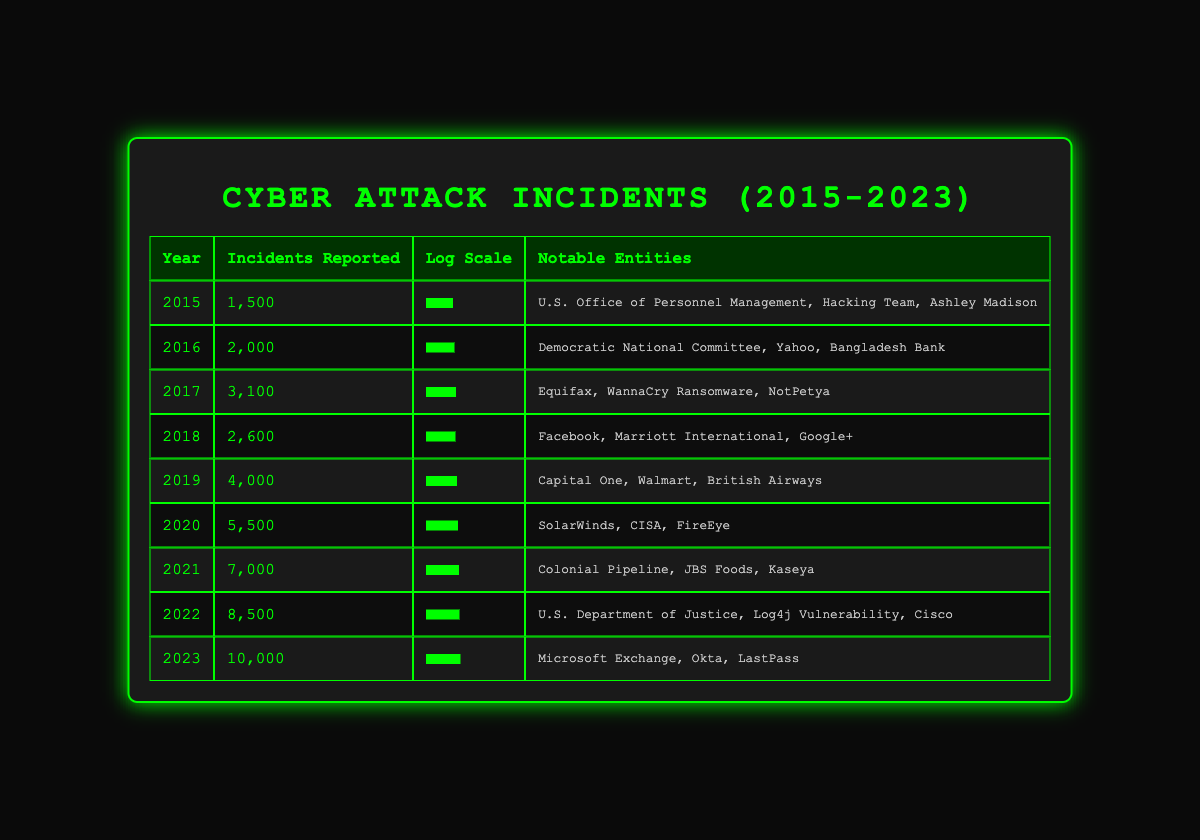What year saw the highest number of reported cyber attack incidents? By examining the "incidents reported" column in the table, we can see that the year 2023 has the highest value at 10,000 incidents reported.
Answer: 2023 How many incidents were reported in 2019? Looking in the table under the year 2019, the number of incidents reported is 4,000.
Answer: 4,000 What is the difference in the number of incidents between 2020 and 2018? From the table, in 2020 there were 5,500 incidents, and in 2018 there were 2,600 incidents. The difference is calculated as 5,500 - 2,600 = 2,900.
Answer: 2,900 Did the number of reported incidents increase from 2015 to 2021? Referring to the table, in 2015 there were 1,500 incidents and in 2021 there were 7,000 incidents. Since 7,000 is greater than 1,500, it confirms there was an increase.
Answer: Yes What is the average number of reported incidents from 2015 to 2023? First, we sum the incidents reported: 1500 + 2000 + 3100 + 2600 + 4000 + 5500 + 7000 + 8500 + 10000 = 50,700. Then, we divide by the number of years (2023 - 2015 + 1) = 9. So, the average is 50,700 / 9 = approximately 5,633.33.
Answer: Approximately 5,633.33 Which year had notable entities that include "SolarWinds"? Looking through the "notable entities" column, "SolarWinds" is listed under the year 2020.
Answer: 2020 How many notable entities were reported in 2022? In the row for 2022, three notable entities are listed: U.S. Department of Justice, Log4j Vulnerability, and Cisco, making the total three.
Answer: 3 Is there a year in this table where the number of incidents reported exceeded 8,000? By scanning the table, we find that 2022 (8,500) and 2023 (10,000) both exceed 8,000 incidents, confirming that there are such years.
Answer: Yes What year had the lowest number of reported cyber attack incidents? Referencing the table, the year 2015 had the lowest count of incidents reported, which was 1,500.
Answer: 2015 